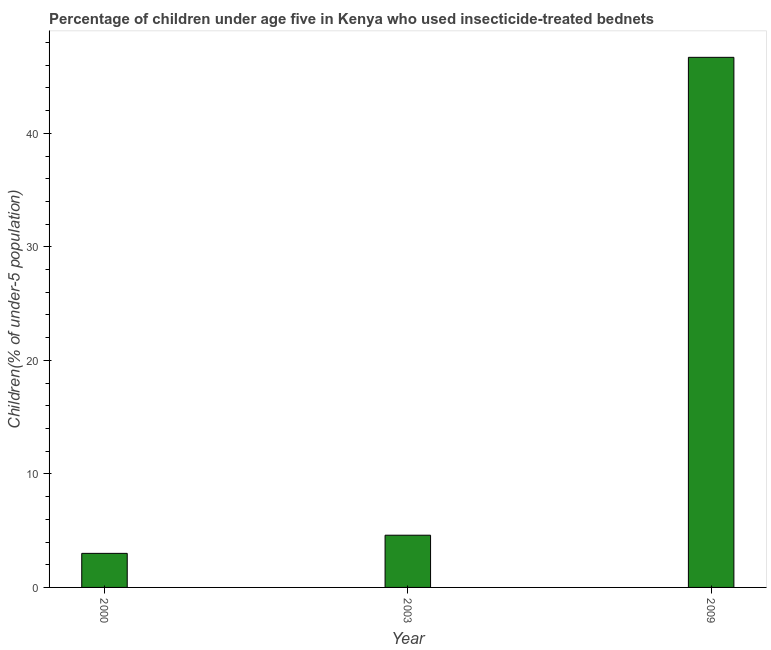What is the title of the graph?
Your response must be concise. Percentage of children under age five in Kenya who used insecticide-treated bednets. What is the label or title of the Y-axis?
Offer a terse response. Children(% of under-5 population). What is the percentage of children who use of insecticide-treated bed nets in 2000?
Make the answer very short. 3. Across all years, what is the maximum percentage of children who use of insecticide-treated bed nets?
Your answer should be compact. 46.7. In which year was the percentage of children who use of insecticide-treated bed nets maximum?
Give a very brief answer. 2009. What is the sum of the percentage of children who use of insecticide-treated bed nets?
Ensure brevity in your answer.  54.3. What is the difference between the percentage of children who use of insecticide-treated bed nets in 2000 and 2009?
Make the answer very short. -43.7. What is the ratio of the percentage of children who use of insecticide-treated bed nets in 2000 to that in 2003?
Offer a terse response. 0.65. Is the percentage of children who use of insecticide-treated bed nets in 2003 less than that in 2009?
Make the answer very short. Yes. What is the difference between the highest and the second highest percentage of children who use of insecticide-treated bed nets?
Your answer should be compact. 42.1. Is the sum of the percentage of children who use of insecticide-treated bed nets in 2000 and 2009 greater than the maximum percentage of children who use of insecticide-treated bed nets across all years?
Offer a very short reply. Yes. What is the difference between the highest and the lowest percentage of children who use of insecticide-treated bed nets?
Offer a terse response. 43.7. Are the values on the major ticks of Y-axis written in scientific E-notation?
Offer a very short reply. No. What is the Children(% of under-5 population) of 2000?
Give a very brief answer. 3. What is the Children(% of under-5 population) in 2009?
Your response must be concise. 46.7. What is the difference between the Children(% of under-5 population) in 2000 and 2003?
Keep it short and to the point. -1.6. What is the difference between the Children(% of under-5 population) in 2000 and 2009?
Make the answer very short. -43.7. What is the difference between the Children(% of under-5 population) in 2003 and 2009?
Ensure brevity in your answer.  -42.1. What is the ratio of the Children(% of under-5 population) in 2000 to that in 2003?
Your answer should be compact. 0.65. What is the ratio of the Children(% of under-5 population) in 2000 to that in 2009?
Your answer should be compact. 0.06. What is the ratio of the Children(% of under-5 population) in 2003 to that in 2009?
Offer a very short reply. 0.1. 